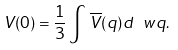Convert formula to latex. <formula><loc_0><loc_0><loc_500><loc_500>V ( 0 ) = \frac { 1 } { 3 } \int \, \overline { V } ( q ) d \ w q .</formula> 